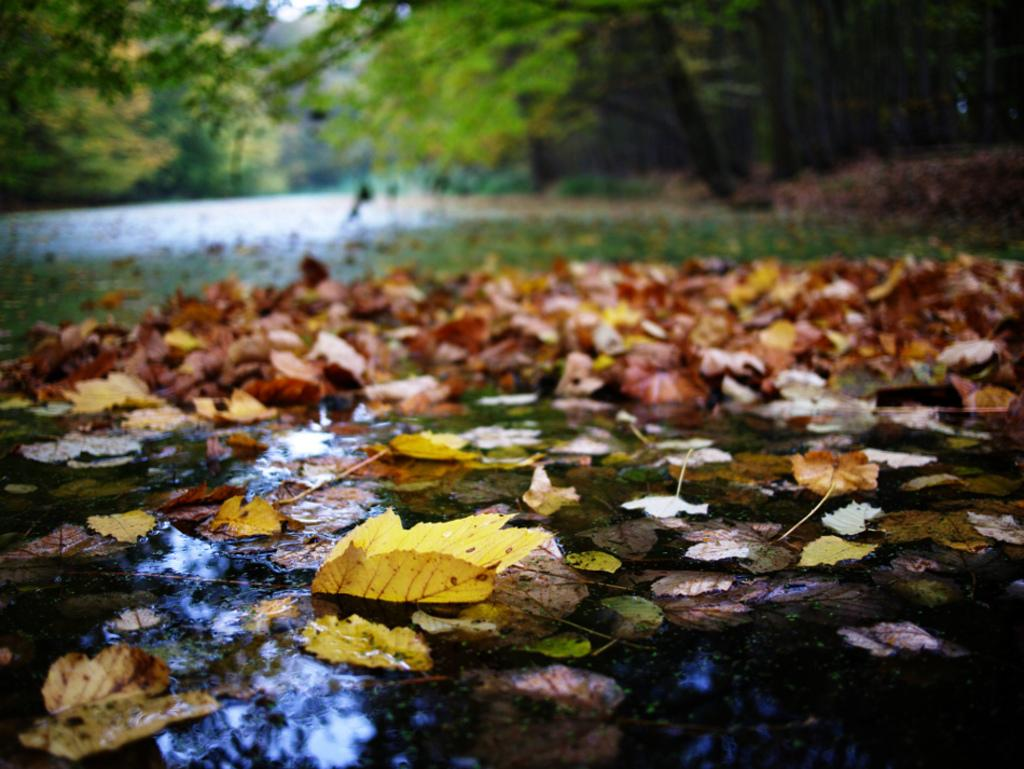What type of vegetation can be seen in the image? There are leaves in the image. What colors are the leaves in the image? The leaves are in yellow, brown, and green colors. What else is visible in the image besides the leaves? There is water visible in the image. What can be seen in the background of the image? There are trees in the background of the image. Where is the boot located in the image? There is no boot present in the image. Can you see any corn growing in the image? There is no corn visible in the image. 